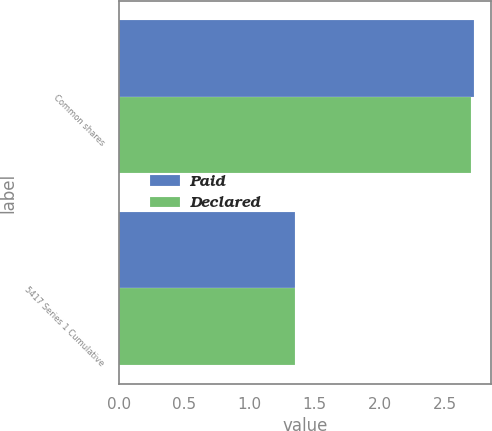Convert chart to OTSL. <chart><loc_0><loc_0><loc_500><loc_500><stacked_bar_chart><ecel><fcel>Common shares<fcel>5417 Series 1 Cumulative<nl><fcel>Paid<fcel>2.72<fcel>1.35<nl><fcel>Declared<fcel>2.7<fcel>1.35<nl></chart> 